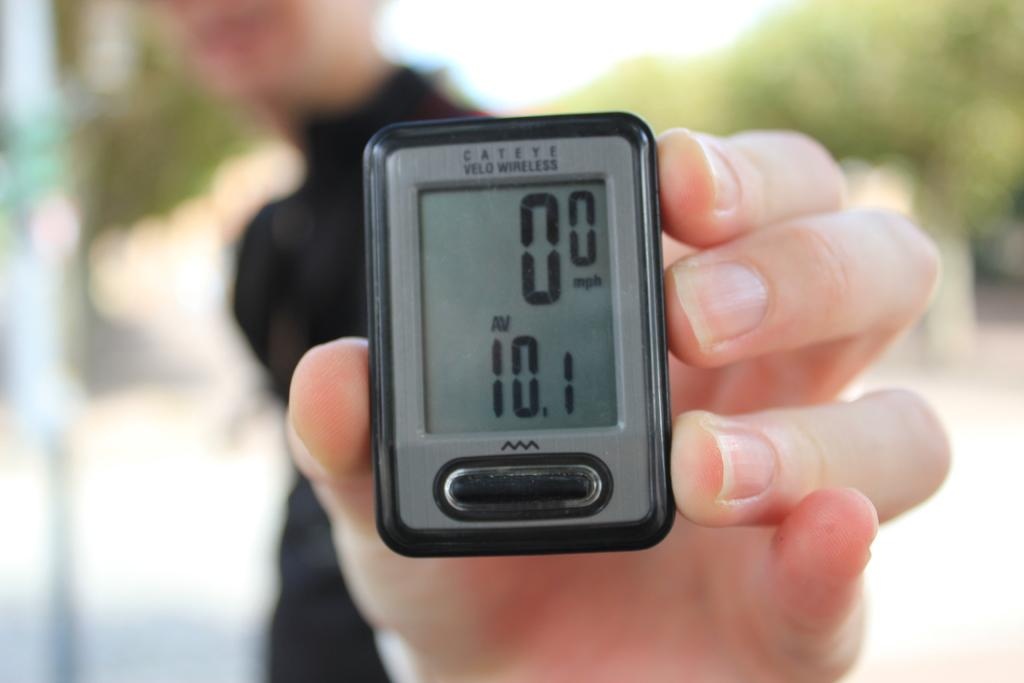What is the main subject of the image? There is a person in the image. What is the person holding in the image? The person is holding a device. Can you describe the device? The device has text and buttons on it. What can be seen in the background of the image? The background of the image is blurry, and there appears to be a tree in the blurry background. What language is the person speaking in the image? The image does not provide any information about the language being spoken, as it only shows a person holding a device with text and buttons. What scent can be detected from the device in the image? There is no information about any scent associated with the device in the image. 